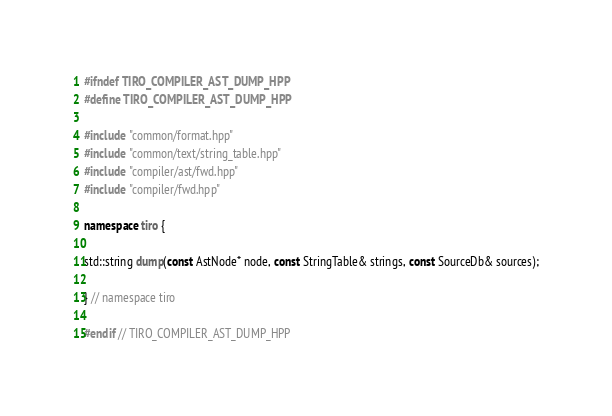<code> <loc_0><loc_0><loc_500><loc_500><_C++_>#ifndef TIRO_COMPILER_AST_DUMP_HPP
#define TIRO_COMPILER_AST_DUMP_HPP

#include "common/format.hpp"
#include "common/text/string_table.hpp"
#include "compiler/ast/fwd.hpp"
#include "compiler/fwd.hpp"

namespace tiro {

std::string dump(const AstNode* node, const StringTable& strings, const SourceDb& sources);

} // namespace tiro

#endif // TIRO_COMPILER_AST_DUMP_HPP
</code> 